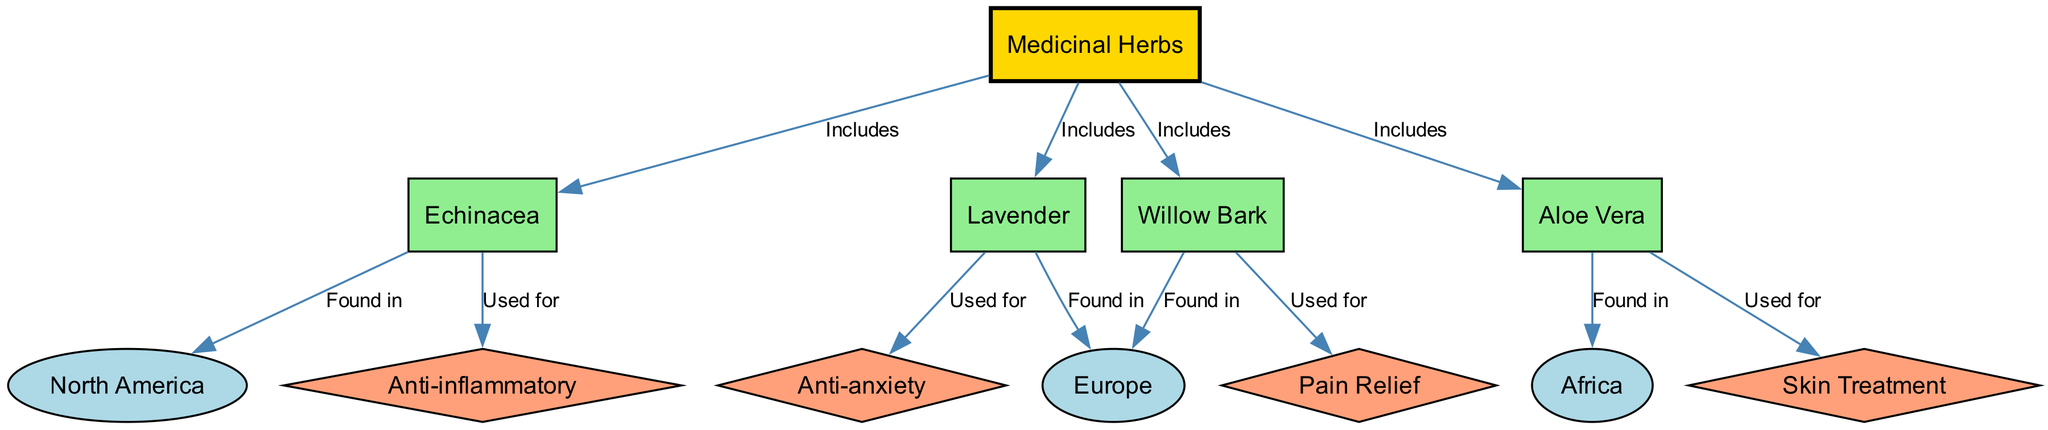What is the total number of medicinal herbs shown in the diagram? The diagram lists four medicinal herbs: Echinacea, Lavender, Willow Bark, and Aloe Vera. By counting these distinct nodes under the "Medicinal Herbs" category, we determine that the total is four.
Answer: 4 Which geographic location is Echinacea found in? The diagram indicates that Echinacea is specifically mentioned to be found in North America. This is shown as an edge connecting Echinacea to the North America node.
Answer: North America What is the primary use associated with Willow Bark? According to the diagram, Willow Bark is linked to the use of Pain Relief. This relationship is displayed as an edge from Willow Bark to the Pain Relief node.
Answer: Pain Relief How many edges connect the medicinal herbs to their uses? The herbs are connected to their respective uses with a total of four edges: Echinacea to Anti-inflammatory, Lavender to Anti-anxiety, Willow Bark to Pain Relief, and Aloe Vera to Skin Treatment. Summing the edges gives us four connections.
Answer: 4 Which herb is associated with Skin Treatment? The diagram shows that Aloe Vera is specifically connected to the use of Skin Treatment, indicated by an edge leading to that node.
Answer: Aloe Vera Which countries or continents are mentioned in the diagram? The diagram features three geographic locations: North America, Europe, and Africa. These are noted as distinct nodes connected to different herbs.
Answer: North America, Europe, Africa Which healing properties are Echinacea and Lavender known for? Echinacea is known for its anti-inflammatory properties, while Lavender is associated with anti-anxiety uses. The diagram shows edges from each herb to their respective uses, allowing us to identify these properties easily.
Answer: Anti-inflammatory and Anti-anxiety Is there any overlap in the geographic regions where these medicinal herbs are found? Upon examining the diagram, each herb is associated with a unique geographic region, leading us to conclude that there is no overlap. Echinacea is in North America, Lavender and Willow Bark are in Europe, and Aloe Vera is in Africa, confirming they all occupy distinct locations.
Answer: No Which herb is categorized under the use of Anti-anxiety? The diagram clearly connects Lavender to the use of Anti-anxiety, as indicated by an edge drawn from Lavender to the Anti-anxiety node.
Answer: Lavender 